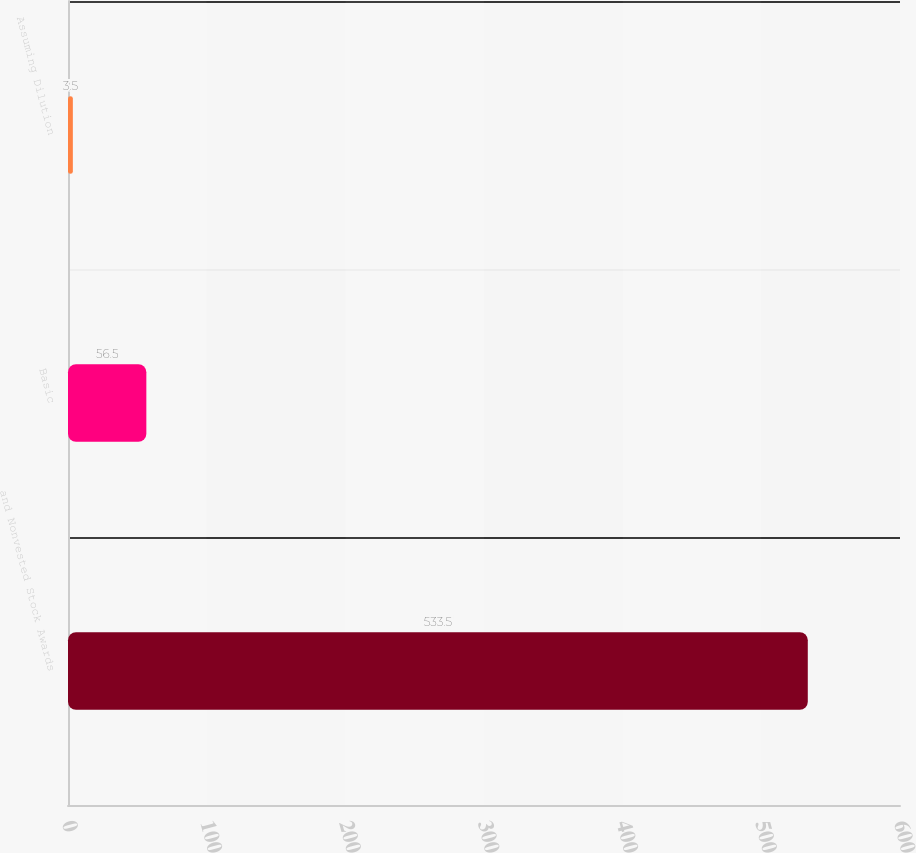Convert chart. <chart><loc_0><loc_0><loc_500><loc_500><bar_chart><fcel>and Nonvested Stock Awards<fcel>Basic<fcel>Assuming Dilution<nl><fcel>533.5<fcel>56.5<fcel>3.5<nl></chart> 